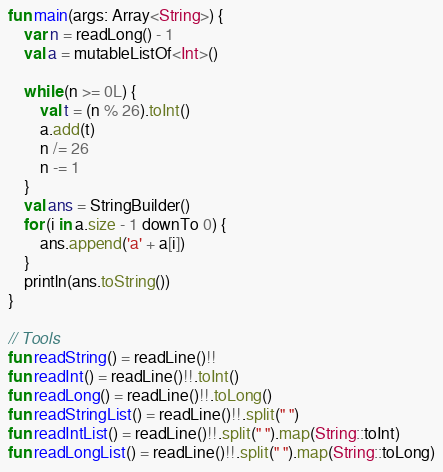<code> <loc_0><loc_0><loc_500><loc_500><_Kotlin_>fun main(args: Array<String>) {
    var n = readLong() - 1
    val a = mutableListOf<Int>()

    while (n >= 0L) {
        val t = (n % 26).toInt()
        a.add(t)
        n /= 26
        n -= 1
    }
    val ans = StringBuilder()
    for (i in a.size - 1 downTo 0) {
        ans.append('a' + a[i])
    }
    println(ans.toString())
}

// Tools
fun readString() = readLine()!!
fun readInt() = readLine()!!.toInt()
fun readLong() = readLine()!!.toLong()
fun readStringList() = readLine()!!.split(" ")
fun readIntList() = readLine()!!.split(" ").map(String::toInt)
fun readLongList() = readLine()!!.split(" ").map(String::toLong)</code> 